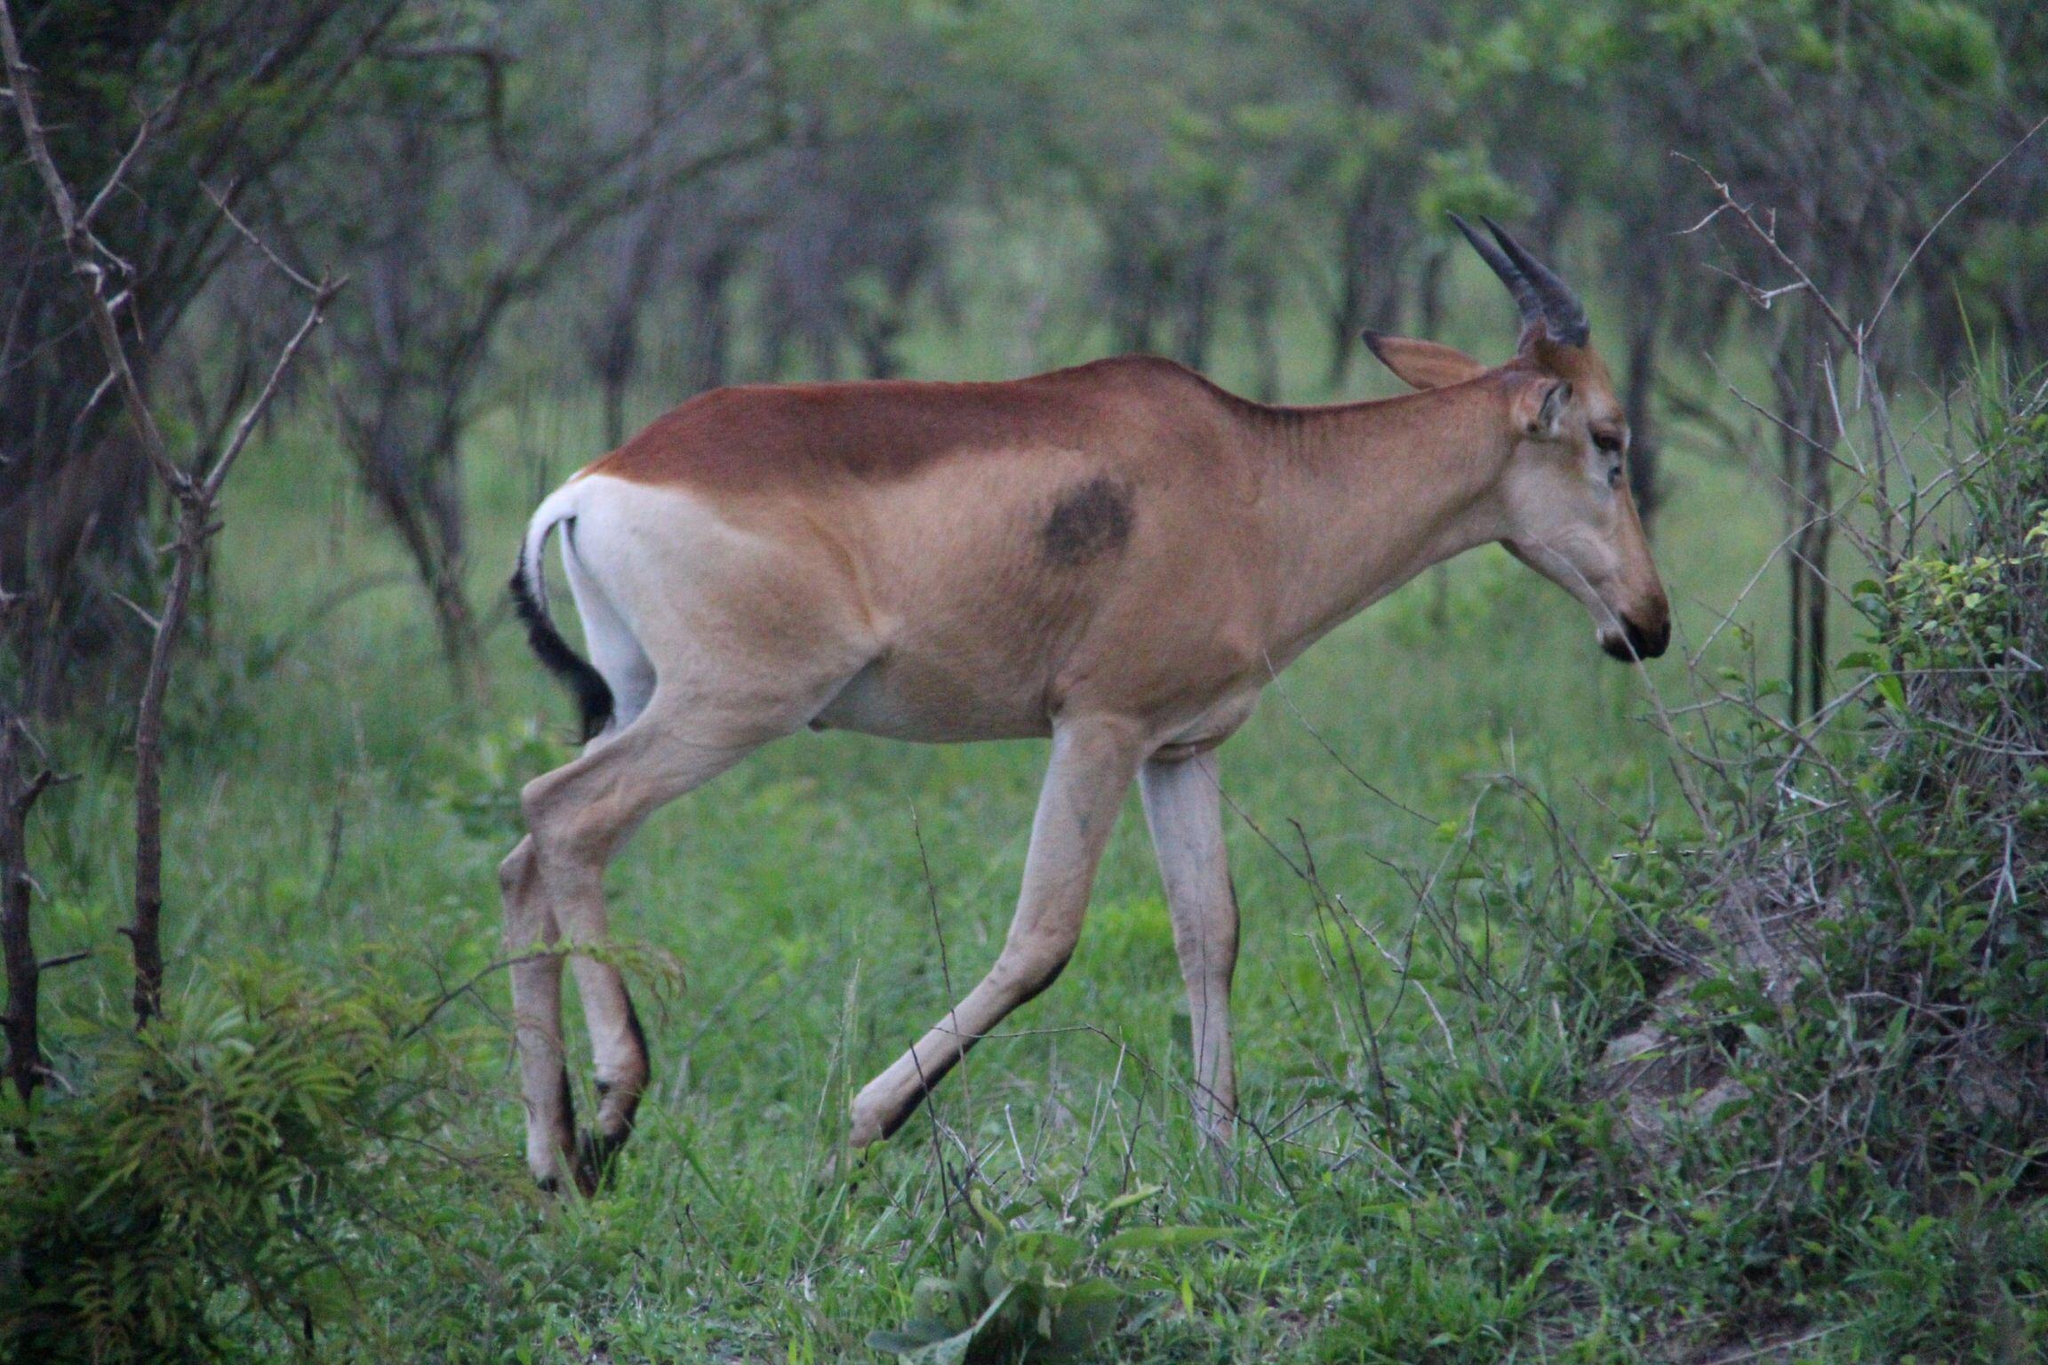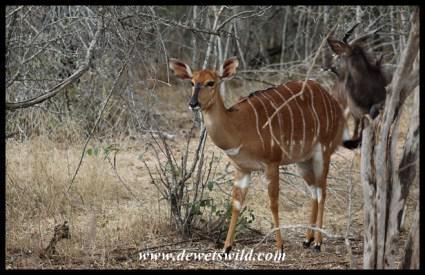The first image is the image on the left, the second image is the image on the right. Examine the images to the left and right. Is the description "There is exactly one animal standing in the right image." accurate? Answer yes or no. Yes. The first image is the image on the left, the second image is the image on the right. Considering the images on both sides, is "The left image includes more than twice the number of horned animals as the right image." valid? Answer yes or no. No. 